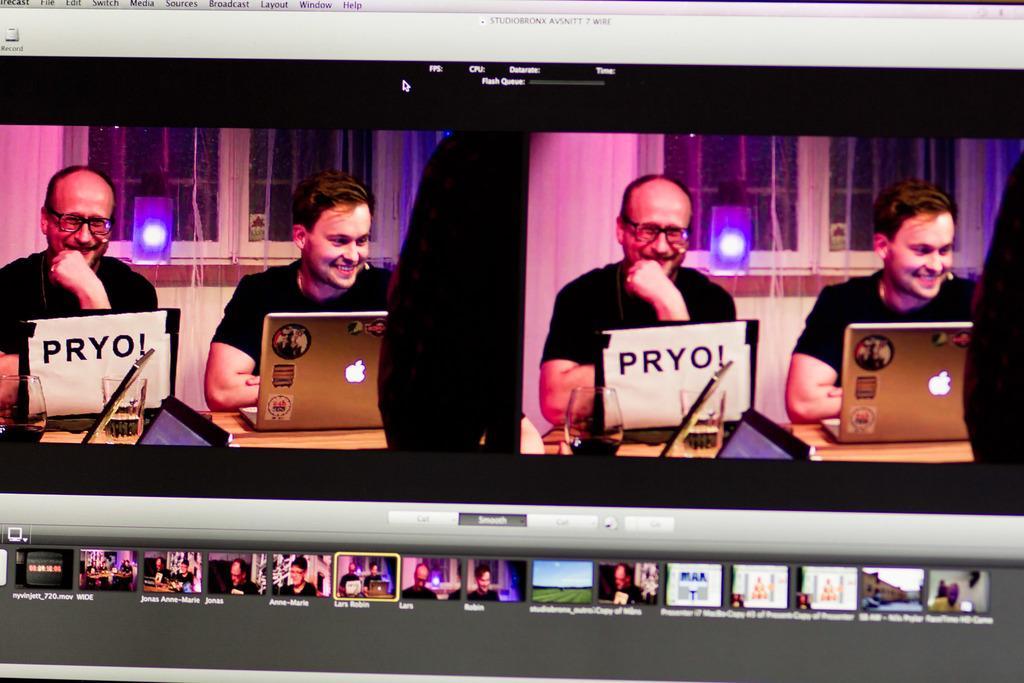Describe this image in one or two sentences. It is a screenshot taken from the screen,there are two people sitting in front of the laptops and behind the people there is a speaker with a light and behind the speaker there is a window. 